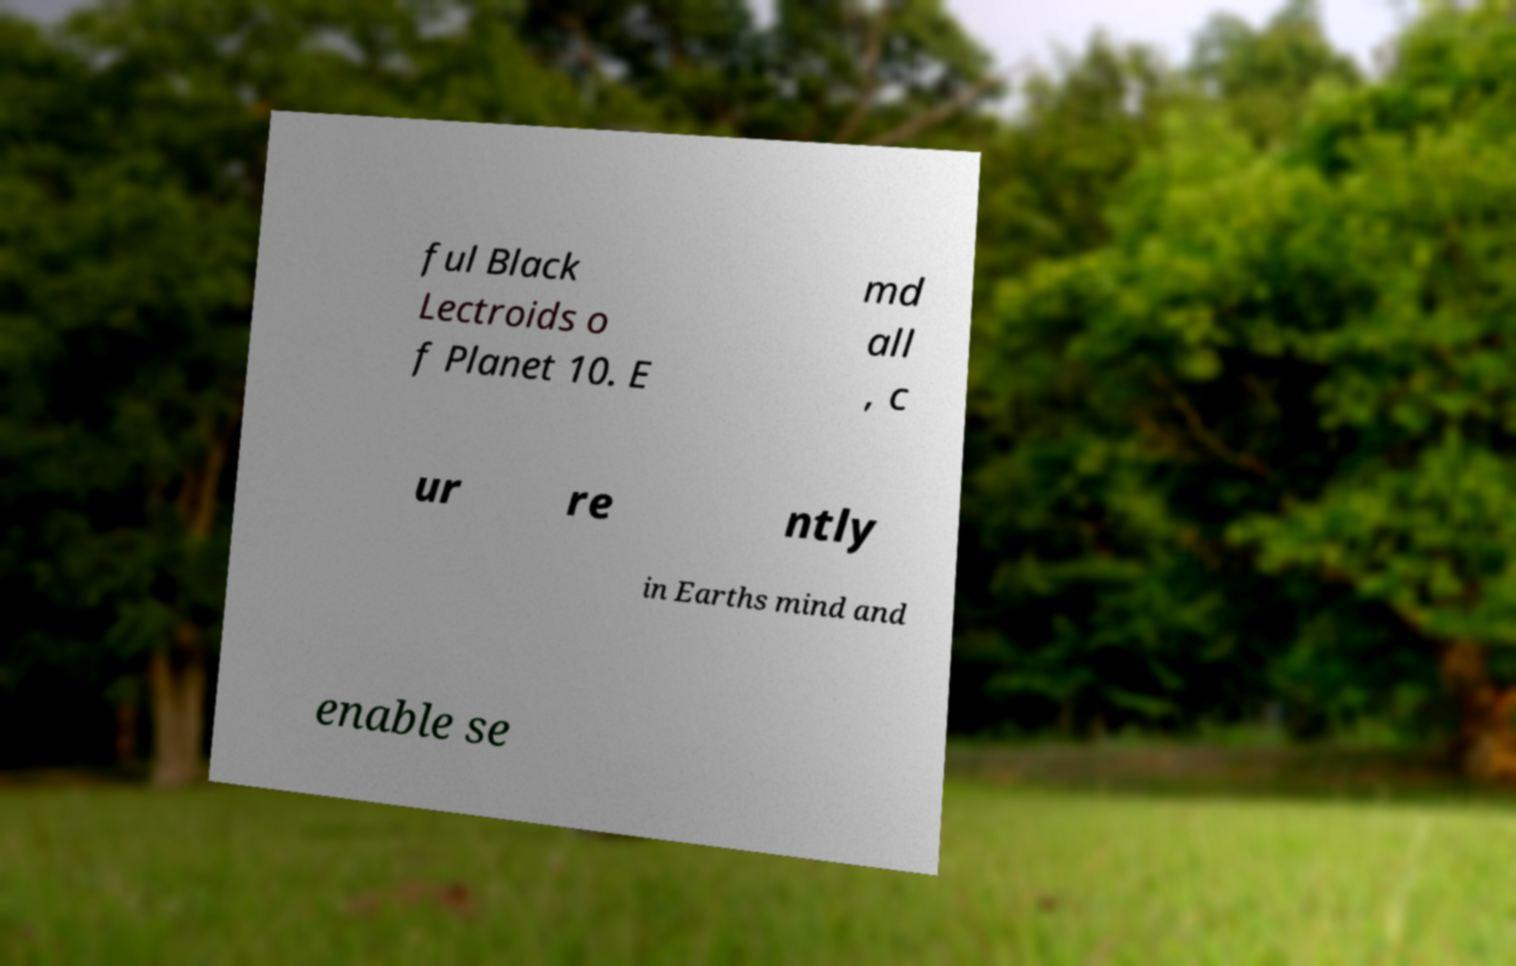Can you read and provide the text displayed in the image?This photo seems to have some interesting text. Can you extract and type it out for me? ful Black Lectroids o f Planet 10. E md all , c ur re ntly in Earths mind and enable se 